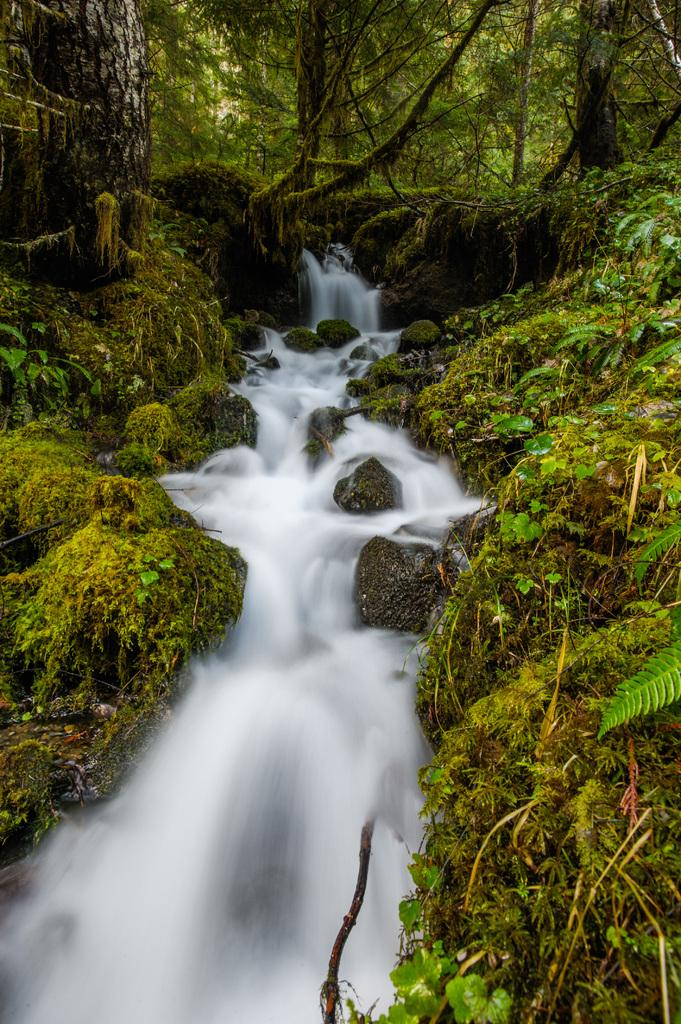What is the main feature in the middle of the image? There is a stream in the middle of the image. What can be seen in the background of the image? There are trees in the background of the image. How much profit does the blade generate in the image? There is no blade or mention of profit in the image; it features a stream and trees. 